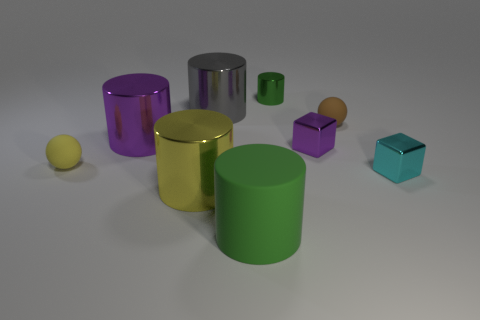The small brown thing that is the same material as the yellow ball is what shape?
Offer a terse response. Sphere. Is the number of small purple metal blocks that are in front of the large green cylinder less than the number of tiny yellow balls?
Provide a short and direct response. Yes. What color is the tiny ball on the right side of the large purple metal object?
Ensure brevity in your answer.  Brown. There is another cylinder that is the same color as the small shiny cylinder; what is its material?
Offer a terse response. Rubber. Is there a big gray thing of the same shape as the green shiny thing?
Your answer should be very brief. Yes. What number of tiny green objects are the same shape as the gray object?
Your response must be concise. 1. Do the large rubber thing and the tiny cylinder have the same color?
Provide a succinct answer. Yes. Are there fewer large objects than purple blocks?
Provide a succinct answer. No. There is a tiny cylinder that is behind the big purple metallic object; what is its material?
Provide a succinct answer. Metal. There is a cyan block that is the same size as the brown sphere; what material is it?
Provide a succinct answer. Metal. 